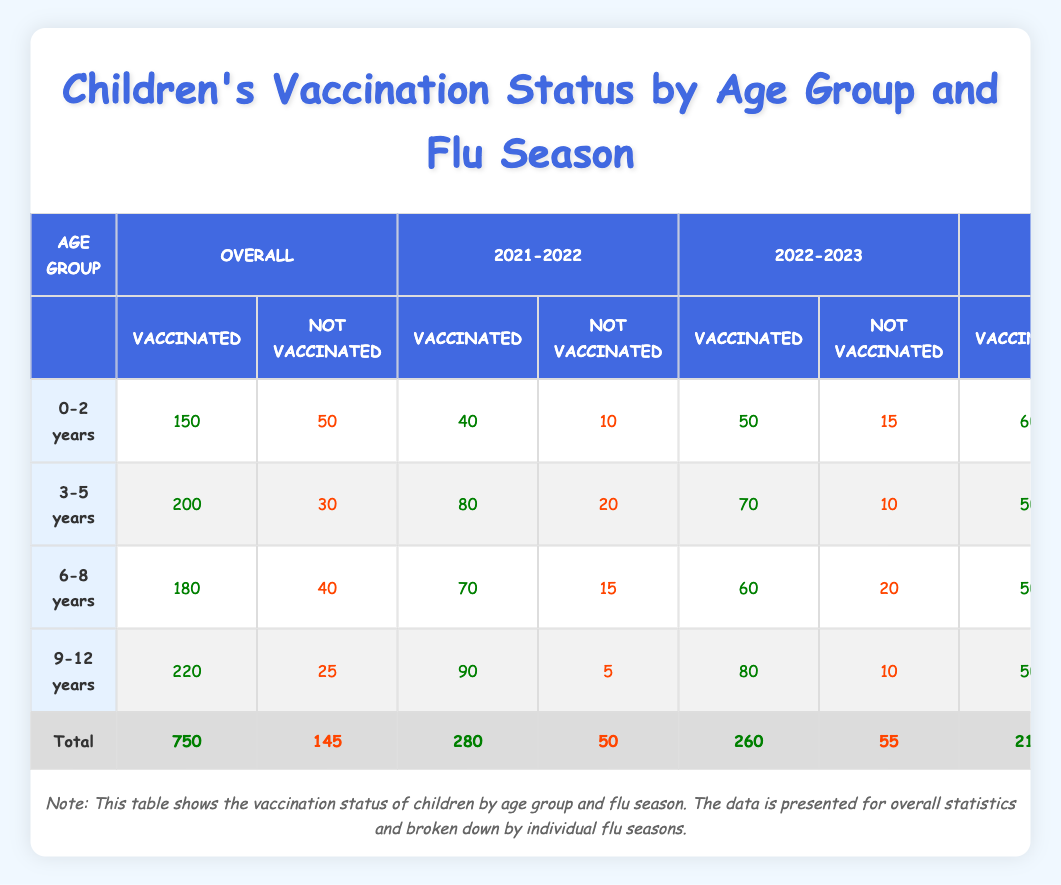What was the total number of vaccinated children in the 2022-2023 season? To find the total number of vaccinated children in the 2022-2023 season, I look at the "Vaccinated" column under the "2022-2023" season in each age group. Adding these values gives: 50 + 70 + 60 + 80 = 260.
Answer: 260 Which age group has the highest number of not vaccinated children overall? I compare the "Not Vaccinated" values across all age groups. The values are: 50 (0-2 years), 30 (3-5 years), 40 (6-8 years), and 25 (9-12 years). The highest value is 50 from the 0-2 years age group.
Answer: 0-2 years How many more children were vaccinated in the 9-12 years age group compared to the 6-8 years age group in the 2021-2022 season? First, I find the vaccinated numbers for both age groups in the 2021-2022 season: 90 (9-12 years) and 70 (6-8 years). The difference is 90 - 70 = 20.
Answer: 20 Is the majority of children in the 3-5 years age group vaccinated in the 2023-2024 season? I check the vaccinated and not vaccinated counts for the 3-5 years age group in the 2023-2024 season: 50 vaccinated and 5 not vaccinated. Since 50 > 5, the majority are vaccinated.
Answer: Yes What percentage of 6-8 years old children were vaccinated in the 2023-2024 season? For the 6-8 years age group in the 2023-2024 season, the vaccinated count is 50 and the total (vaccinated plus not vaccinated) is 50 + 10 = 60. To find the percentage: (50 / 60) x 100 = 83.33%.
Answer: 83.33% How many total children are vaccinated across all age groups for the 2023-2024 season? To find the total vaccinated for the 2023-2024 season, I add the vaccinated values from all age groups: 60 + 50 + 50 + 50 = 210.
Answer: 210 What is the trend for vaccination numbers from the 2021-2022 season to the 2023-2024 season for the 0-2 years age group? For the 0-2 years age group, the vaccinated counts are 40 in 2021-2022, 50 in 2022-2023, and 60 in 2023-2024. This shows an upward trend in vaccination numbers over the three seasons.
Answer: Upward trend Are there fewer vaccinated children in the 3-5 years age group in 2023-2024 than in the 2022-2023 season? In the 3-5 years age group, there were 70 vaccinated in the 2022-2023 season and only 50 in the 2023-2024 season. Thus, there are fewer vaccinated children in 2023-2024.
Answer: Yes 